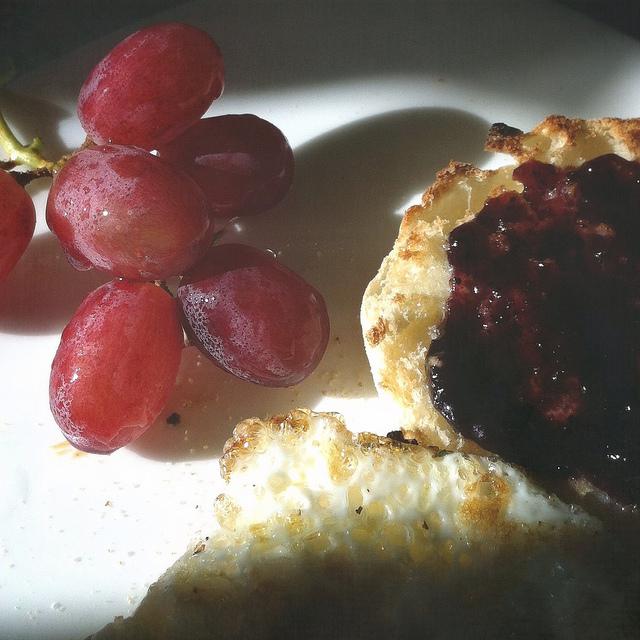Which of these foods could be made into wine?
Keep it brief. Grapes. Would this be considered a meal for an infant?
Give a very brief answer. No. Could you eat this meal for lunch?
Short answer required. Yes. 